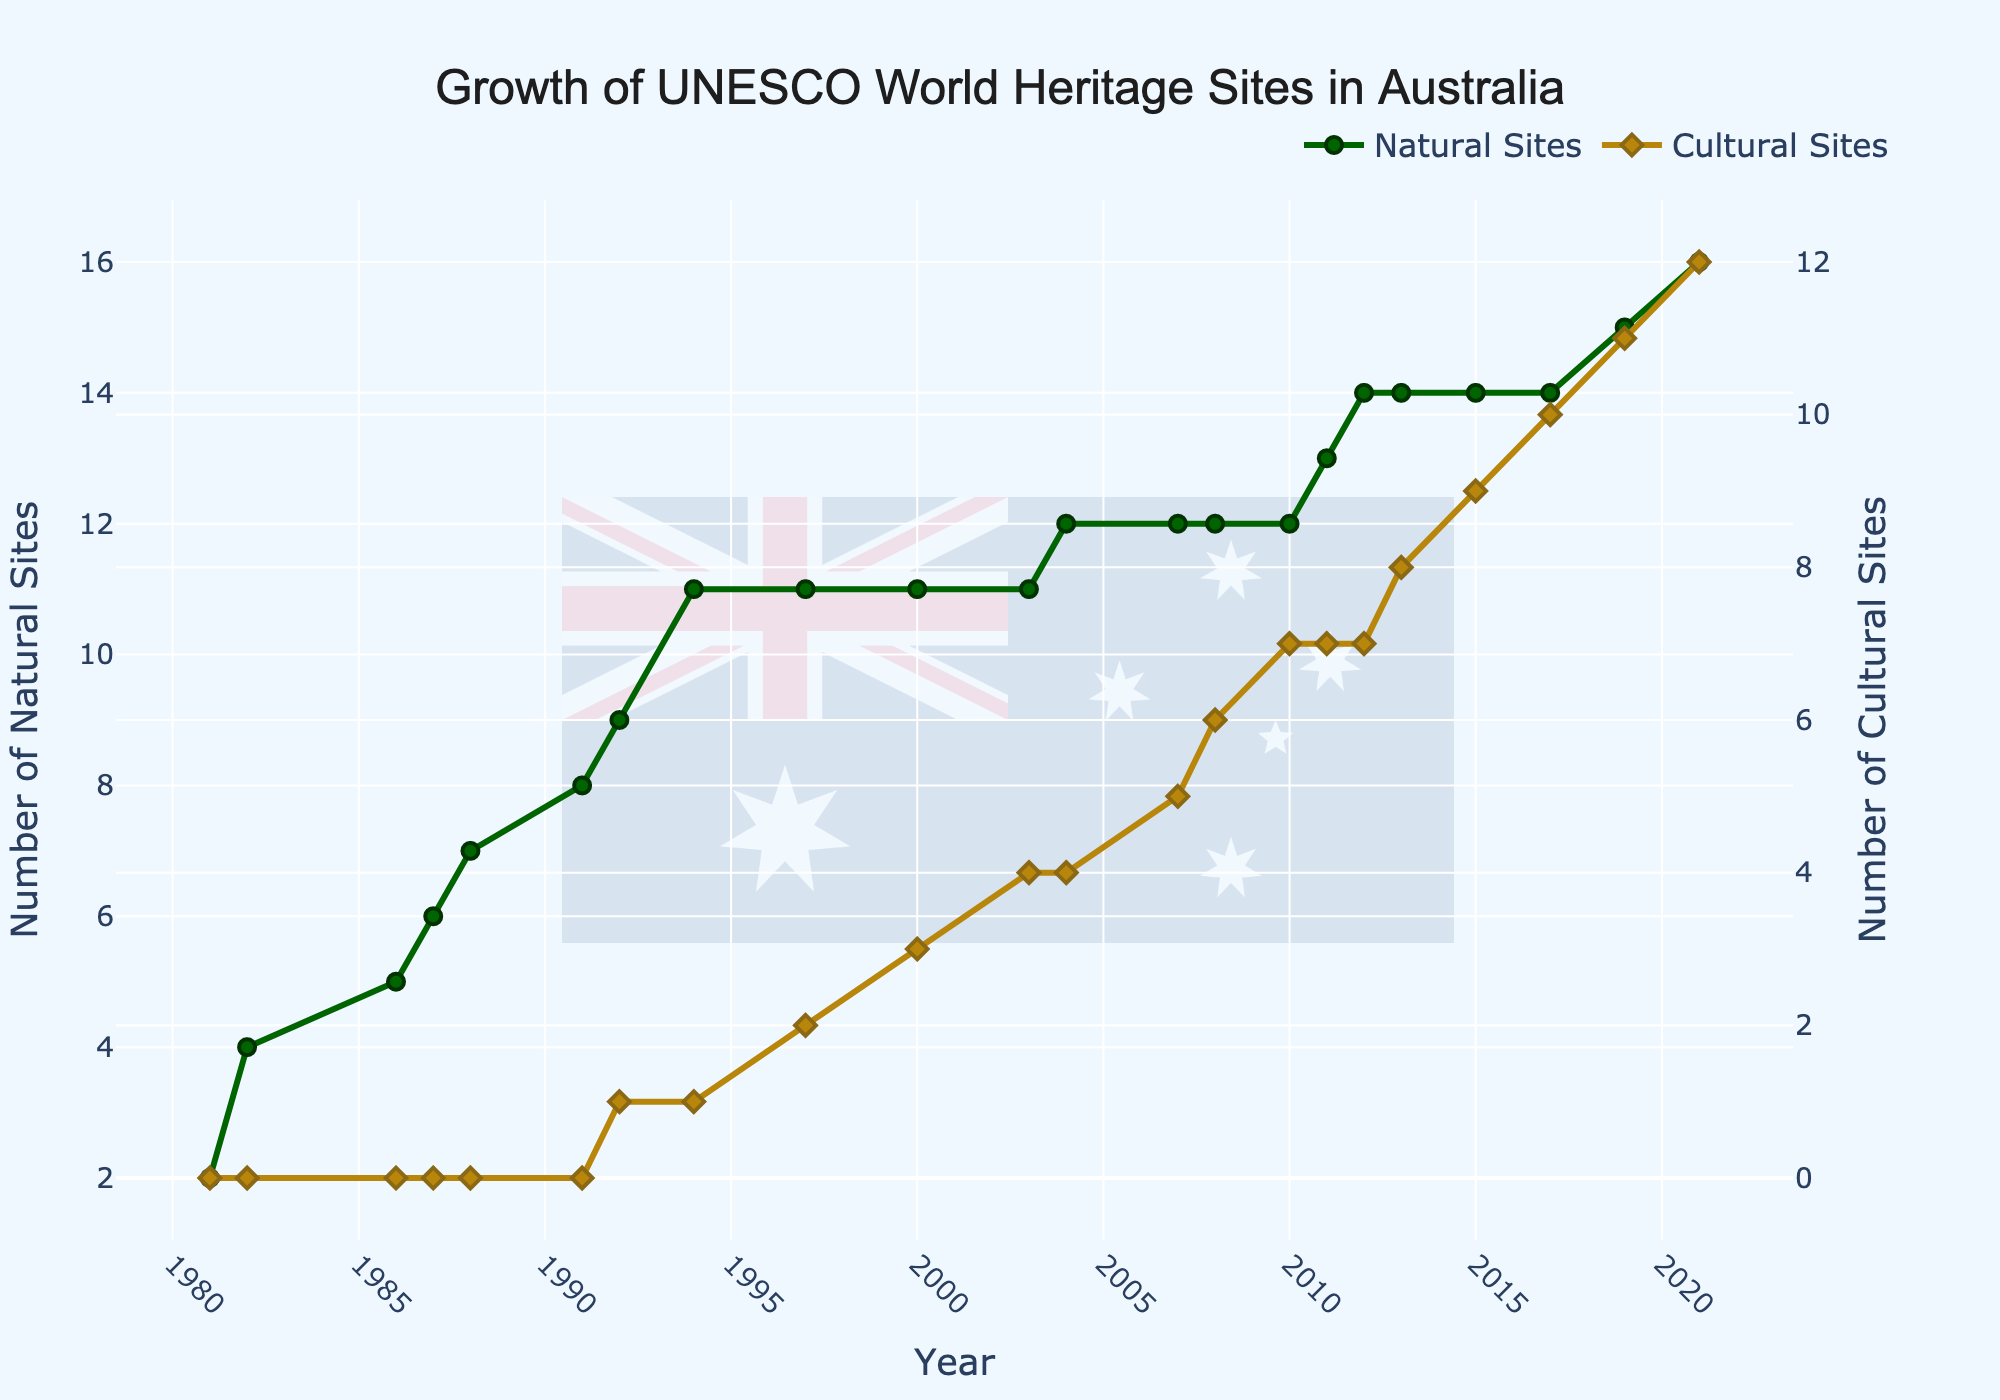Which year had the highest increase in the number of Cultural Sites? By examining the chart, you can see that the highest increase in the number of Cultural Sites occurred between the years where the slope is the steepest. In this case, cultural sites increased from 1 to 2 in 1997, from 3 to 4 in 2003, and so on. However, the biggest jump is from 10 in 2017 to 12 in 2021. Hence, the highest increase happened in 2021.
Answer: 2021 In which year did the number of Cultural Sites first become greater than zero? The figure shows that Cultural Sites were zero until 1992. From 1992 onward, the chart shows an increase with the first site added in 1992.
Answer: 1992 Which type of site saw the greatest increase overall from 1981 to 2021, and by how much did it increase? From the figure, the number of Natural Sites increased from 2 in 1981 to 16 in 2021. Cultural Sites increased from 0 in 1981 to 12 in 2021. The total increase for Natural Sites is 16 - 2 = 14 and for Cultural Sites is 12 - 0 = 12. Comparing these values, Natural Sites had the greatest increase.
Answer: Natural Sites by 14 How many times did the number of Natural Sites increase by one from 1981 to 2021? By inspecting the Natural Sites line, each increase is represented by a step up. Count these steps from 1981 to 2021. In 1981 it starts at 2, and in 2021 it's 16. There were increases at 1982, 1986, 1987, 1988, 1991, 1992, 1994, 2004, 2011, 2012, 2019, and 2021. This can be counted as 12 individual increases.
Answer: 12 Identify the two consecutive years where both Natural and Cultural Sites increased. By examining the figure closely, look for times when both lines move upwards between years. This happens from 2010 to 2011 and from 2020 to 2021.
Answer: 2010-2011 and 2020-2021 